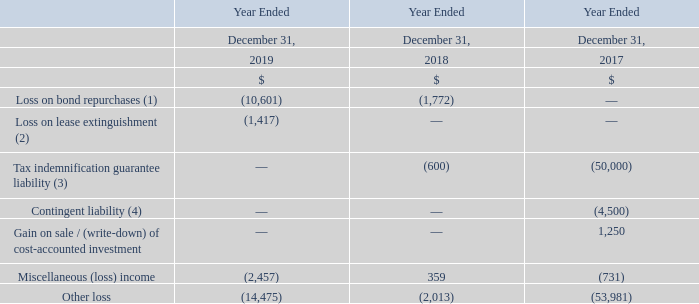Other loss
In May 2019, the Company completed a cash tender offer and purchased $460.9 million in aggregate principal amount of the 2020 Notes and issued $250.0 million in aggregate principal amount of 9.25% senior secured notes at par due November 2022. The Company recognized a loss of $10.6 million on the purchase of the 2020 Notes for the year ended December 31, 2019 (see Note 9).
During September 2019, Teekay LNG refinanced the Torben Spirit by acquiring the Torben Spirit from its original Lessor and then selling the vessel to another Lessor and leasing it back for a period of 7.5 years. As a result of this refinancing transaction, the Partnership recognized a loss of $1.4 million for the year ended December 31, 2019 on the extinguishment of the original finance lease (see Note 11).
Following the termination of the finance lease arrangements for the RasGas II LNG Carriers in 2014, the lessor made a determination that additional rentals were due under the leases following a challenge by the UK taxing authority. As a result, in 2017 the Teekay Nakilat Joint Venture recognized an additional liability, which was included as part of other loss in the Company's consolidated statements of loss.
Related to settlements and accruals made prior to September 2017 as a result of claims and potential claims made against Logitel Offshore Holding AS (or Logitel), a company acquired by Altera in 2014. Altera was deconsolidated in September 2017 (see Note 4).
What was the amount of notes purchased by the company in May 2019? $460.9 million. What was the loss recognized by the company in December 2019? $10.6 million. What was the loss on bond repurchases in 2019, 2018 and 2017?
Answer scale should be: thousand. (10,601), (1,772), 0. What is the average Loss on lease extinguishment?
Answer scale should be: thousand. -(1,417 + 0 + 0) / 3
Answer: -472.33. In which year is the Gain on sale / (write-down) of cost-accounted investment less than 1,000 thousands? Locate and analyze gain on sale / (write-down) of cost-accounted investment in row 9
answer: 2019, 2018. What is the increase / (decrease) in Other loss from 2018 to 2019?
Answer scale should be: thousand. -14,475 - (-2,013)
Answer: -12462. 